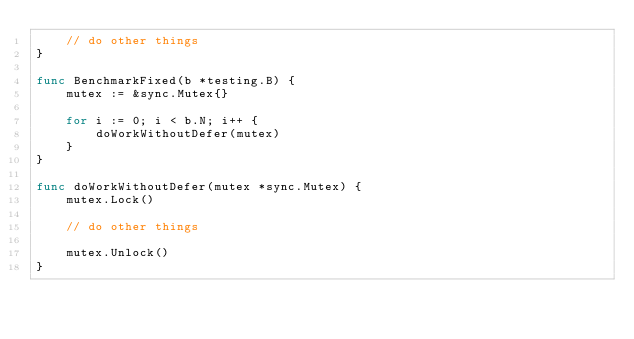Convert code to text. <code><loc_0><loc_0><loc_500><loc_500><_Go_>	// do other things
}

func BenchmarkFixed(b *testing.B) {
	mutex := &sync.Mutex{}

	for i := 0; i < b.N; i++ {
		doWorkWithoutDefer(mutex)
	}
}

func doWorkWithoutDefer(mutex *sync.Mutex) {
	mutex.Lock()

	// do other things

	mutex.Unlock()
}
</code> 